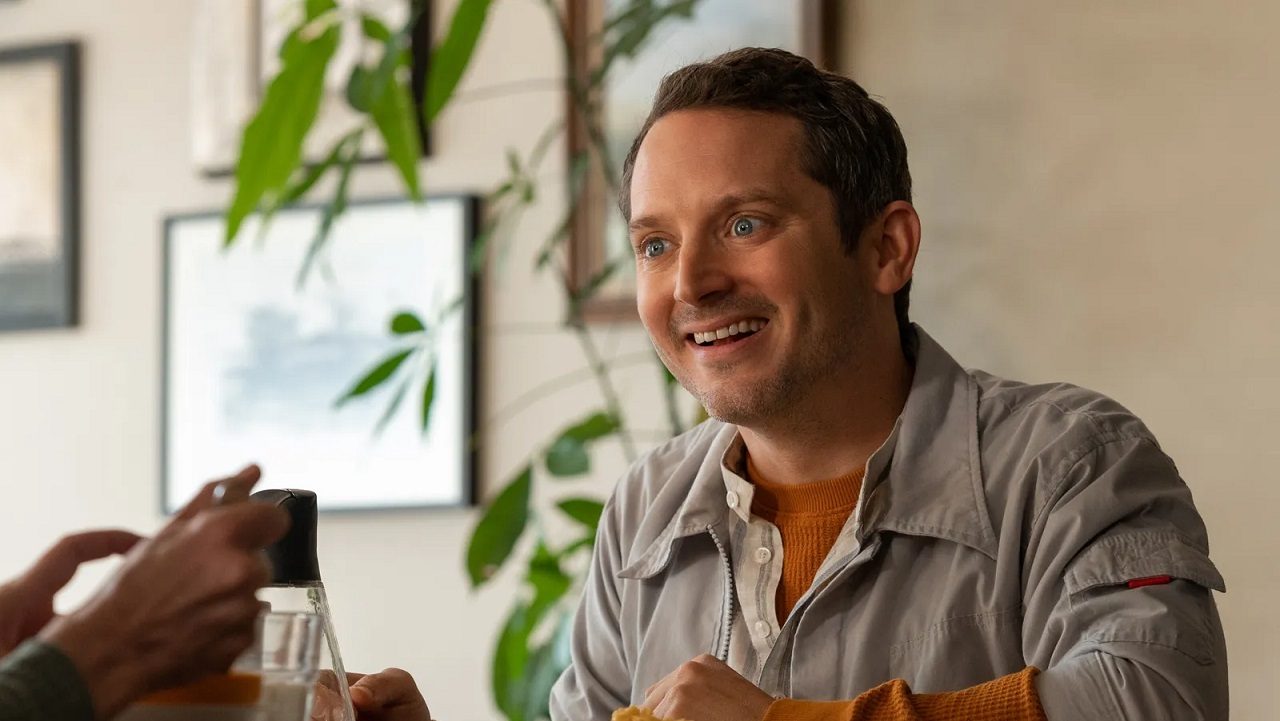If this image were the cover of a novel, what would the title and synopsis be? Title: "Urban Serenade: A Symphony of Solitude"
Synopsis: In the heart of Melodyville, Ethan finds himself at a crossroads in life. Juggling his career, friendships, and the quest for personal fulfillment, he frequents a quaint café that offers him solace amidst the city's chaos. Here, he's often seen smiling, engaged in profound conversations, and savoring tranquil moments. But as secrets from the past resurface and new connections are forged, Ethan embarks on a journey of self-discovery. 'Urban Serenade: A Symphony of Solitude' is a story about finding peace in unexpected places and the transformative power of human connection. 